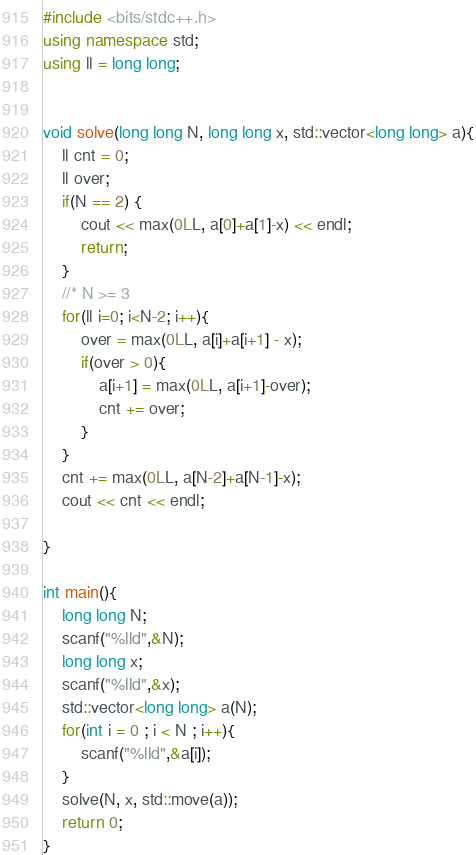Convert code to text. <code><loc_0><loc_0><loc_500><loc_500><_C++_>#include <bits/stdc++.h>
using namespace std;
using ll = long long;


void solve(long long N, long long x, std::vector<long long> a){
    ll cnt = 0;
    ll over;
    if(N == 2) {
        cout << max(0LL, a[0]+a[1]-x) << endl;
        return;
    }
    //* N >= 3
    for(ll i=0; i<N-2; i++){
        over = max(0LL, a[i]+a[i+1] - x);
        if(over > 0){
            a[i+1] = max(0LL, a[i+1]-over);
            cnt += over;
        }
    }
    cnt += max(0LL, a[N-2]+a[N-1]-x);
    cout << cnt << endl;
    
}

int main(){
    long long N;
    scanf("%lld",&N);
    long long x;
    scanf("%lld",&x);
    std::vector<long long> a(N);
    for(int i = 0 ; i < N ; i++){
        scanf("%lld",&a[i]);
    }
    solve(N, x, std::move(a));
    return 0;
}
</code> 